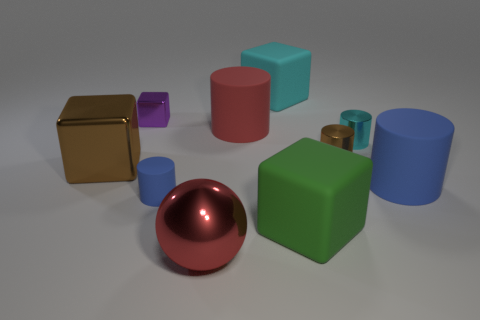Subtract all blue matte cylinders. How many cylinders are left? 3 Subtract all purple cubes. How many cubes are left? 3 Subtract 0 green spheres. How many objects are left? 10 Subtract all cubes. How many objects are left? 6 Subtract 2 cubes. How many cubes are left? 2 Subtract all gray cylinders. Subtract all blue blocks. How many cylinders are left? 5 Subtract all purple balls. How many brown blocks are left? 1 Subtract all large brown cubes. Subtract all big brown shiny blocks. How many objects are left? 8 Add 4 small purple shiny cubes. How many small purple shiny cubes are left? 5 Add 5 tiny gray metallic blocks. How many tiny gray metallic blocks exist? 5 